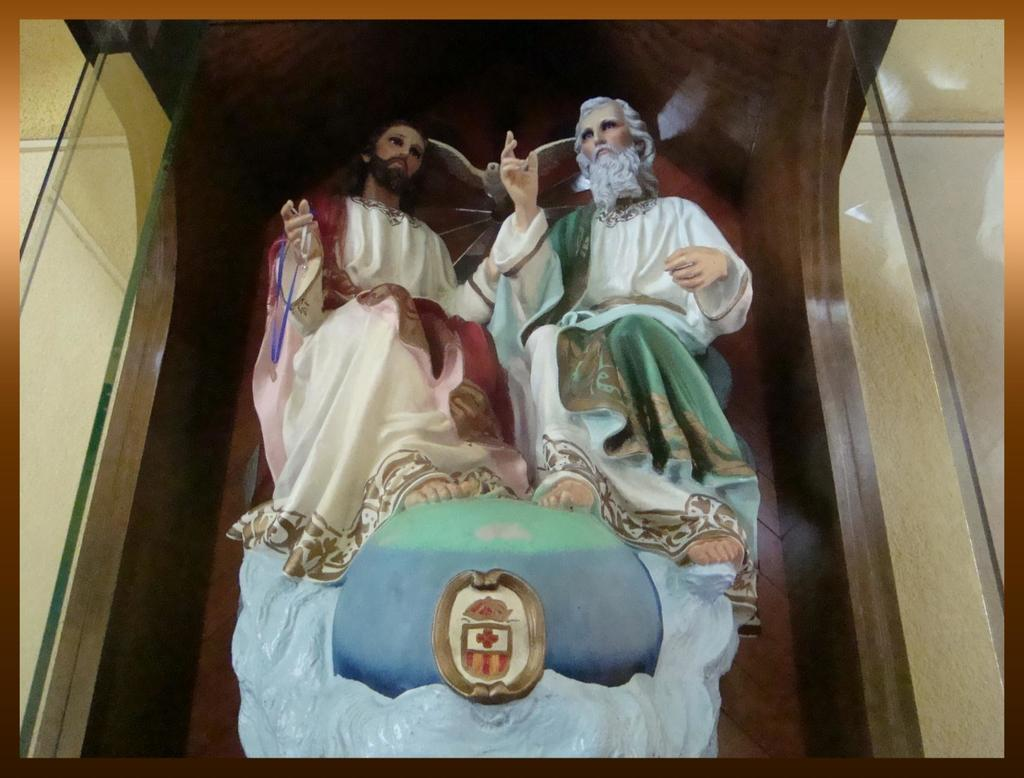What type of objects are depicted in the image? The image contains sculptures of two persons and a bird. How are the sculptures displayed in the image? The sculptures are contained within a glass box. What type of plot is being developed in the image? There is no plot development in the image, as it features sculptures contained within a glass box. Can you tell me where the nearest store is located in the image? There is no store present in the image; it only contains sculptures within a glass box. 